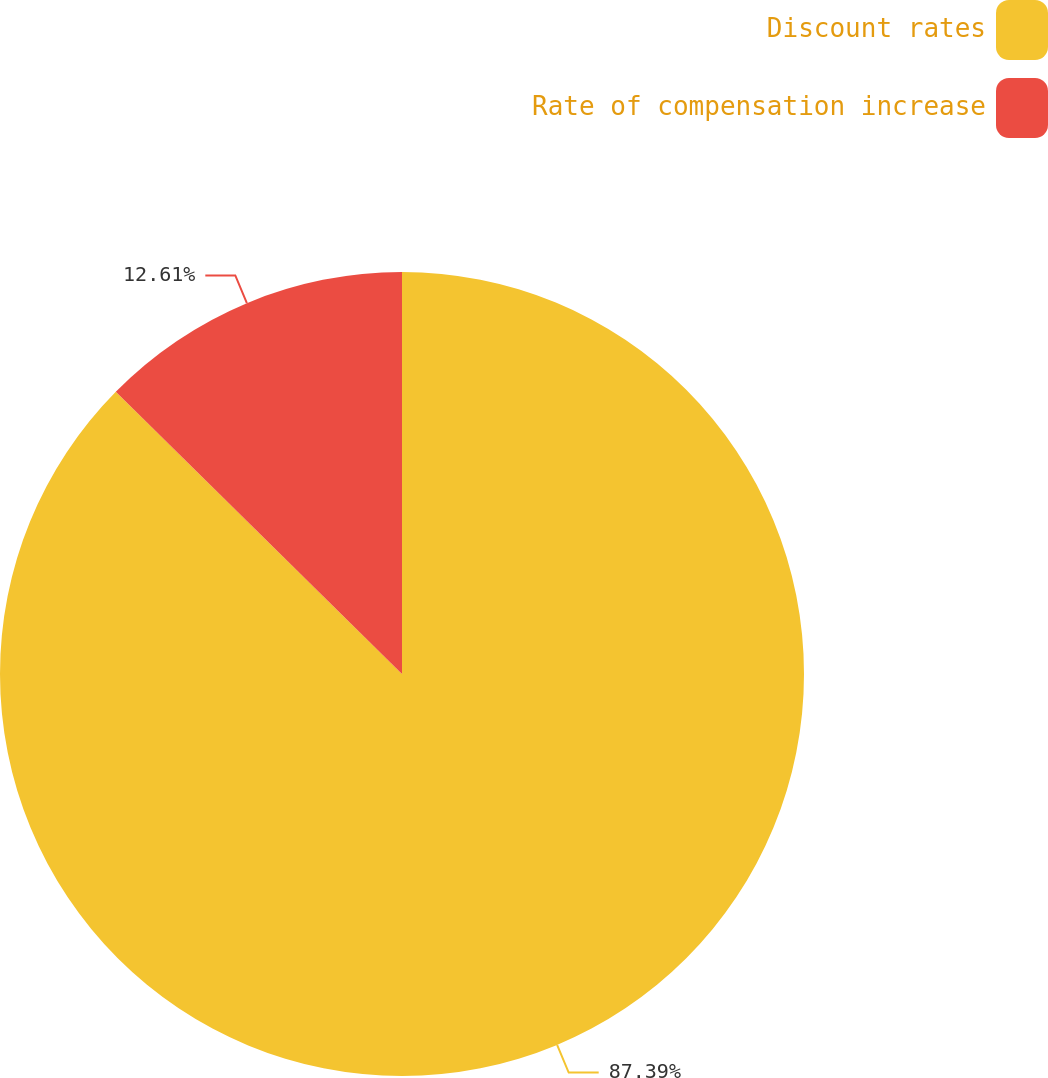Convert chart. <chart><loc_0><loc_0><loc_500><loc_500><pie_chart><fcel>Discount rates<fcel>Rate of compensation increase<nl><fcel>87.39%<fcel>12.61%<nl></chart> 